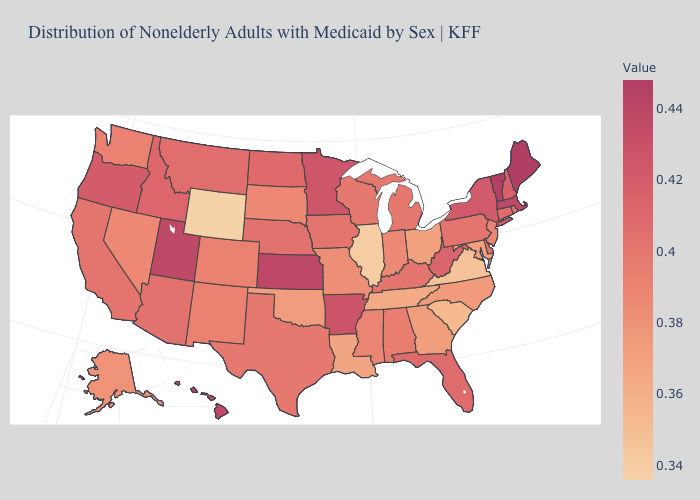Does the map have missing data?
Short answer required. No. Does the map have missing data?
Keep it brief. No. Which states have the lowest value in the West?
Quick response, please. Wyoming. Is the legend a continuous bar?
Keep it brief. Yes. Which states have the lowest value in the MidWest?
Quick response, please. Illinois. Does Nevada have a higher value than Maine?
Be succinct. No. 